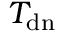<formula> <loc_0><loc_0><loc_500><loc_500>T _ { d n }</formula> 